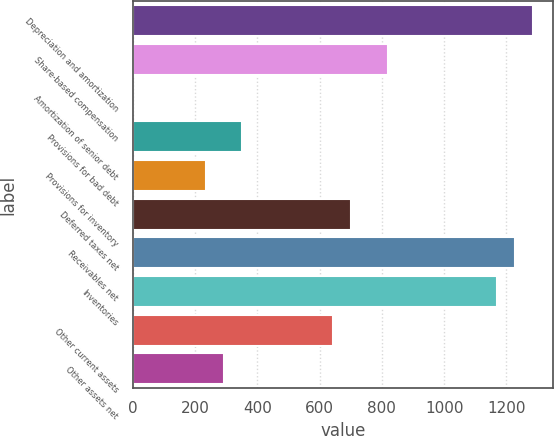<chart> <loc_0><loc_0><loc_500><loc_500><bar_chart><fcel>Depreciation and amortization<fcel>Share-based compensation<fcel>Amortization of senior debt<fcel>Provisions for bad debt<fcel>Provisions for inventory<fcel>Deferred taxes net<fcel>Receivables net<fcel>Inventories<fcel>Other current assets<fcel>Other assets net<nl><fcel>1286.46<fcel>819.02<fcel>1<fcel>351.58<fcel>234.72<fcel>702.16<fcel>1228.03<fcel>1169.6<fcel>643.73<fcel>293.15<nl></chart> 